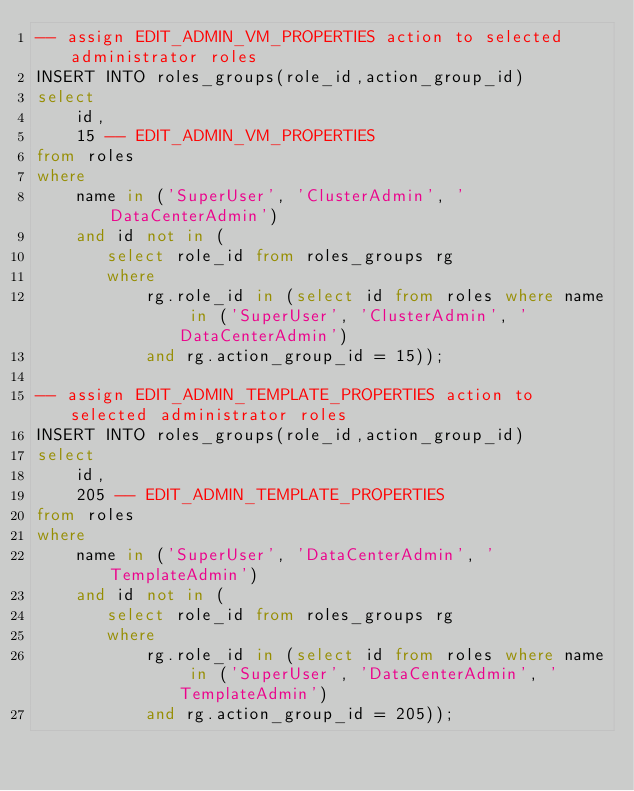<code> <loc_0><loc_0><loc_500><loc_500><_SQL_>-- assign EDIT_ADMIN_VM_PROPERTIES action to selected administrator roles
INSERT INTO roles_groups(role_id,action_group_id)
select
    id,
    15 -- EDIT_ADMIN_VM_PROPERTIES
from roles
where
    name in ('SuperUser', 'ClusterAdmin', 'DataCenterAdmin')
    and id not in (
       select role_id from roles_groups rg
       where
           rg.role_id in (select id from roles where name in ('SuperUser', 'ClusterAdmin', 'DataCenterAdmin')
           and rg.action_group_id = 15));

-- assign EDIT_ADMIN_TEMPLATE_PROPERTIES action to selected administrator roles
INSERT INTO roles_groups(role_id,action_group_id)
select
    id,
    205 -- EDIT_ADMIN_TEMPLATE_PROPERTIES
from roles
where
    name in ('SuperUser', 'DataCenterAdmin', 'TemplateAdmin')
    and id not in (
       select role_id from roles_groups rg
       where
           rg.role_id in (select id from roles where name in ('SuperUser', 'DataCenterAdmin', 'TemplateAdmin')
           and rg.action_group_id = 205));
</code> 